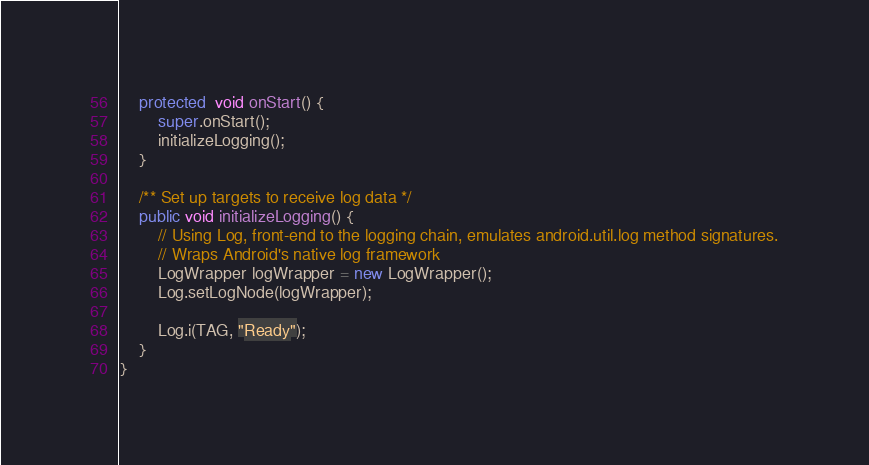<code> <loc_0><loc_0><loc_500><loc_500><_Java_>    protected  void onStart() {
        super.onStart();
        initializeLogging();
    }

    /** Set up targets to receive log data */
    public void initializeLogging() {
        // Using Log, front-end to the logging chain, emulates android.util.log method signatures.
        // Wraps Android's native log framework
        LogWrapper logWrapper = new LogWrapper();
        Log.setLogNode(logWrapper);

        Log.i(TAG, "Ready");
    }
}
</code> 